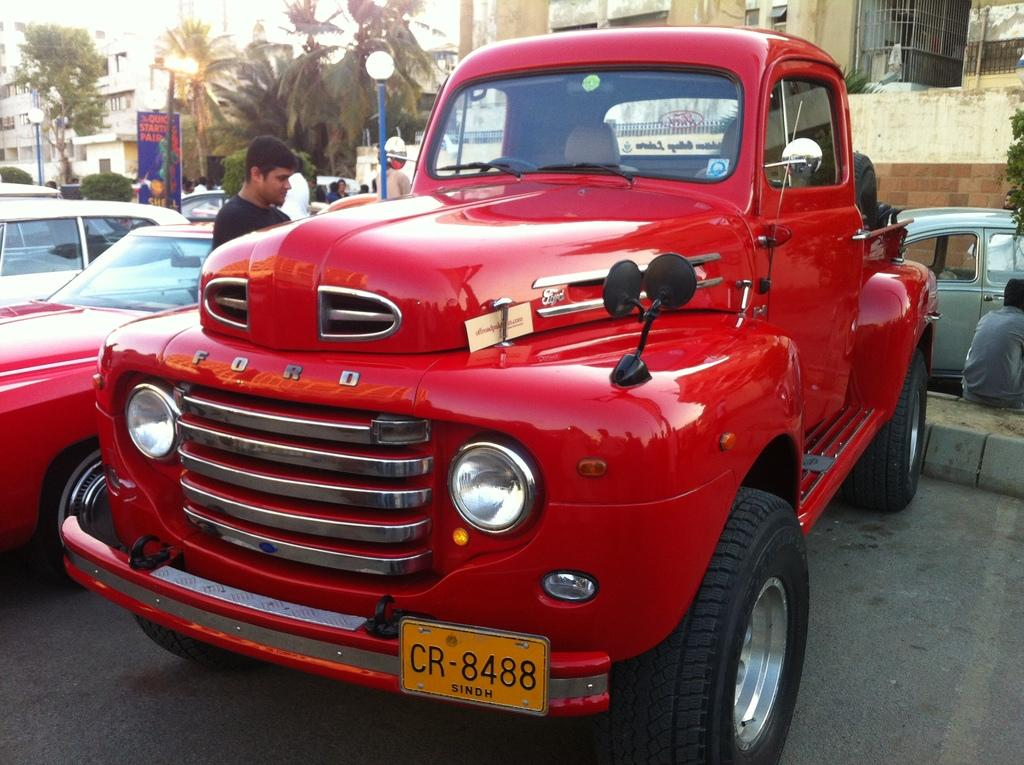What can be seen on the road in the image? There are cars on the road in the image. What are the people behind the cars doing? The people are standing behind the cars. What can be seen in the distance in the image? There are buildings in the background of the image. What type of vegetation is present in front of the buildings? Trees are present in front of the buildings. What type of shoe can be seen on the roof of the building in the image? There is no shoe present on the roof of the building in the image. What season is it in the image, considering the presence of trees and buildings? The season cannot be determined from the image, as it only shows cars, people, buildings, and trees. 